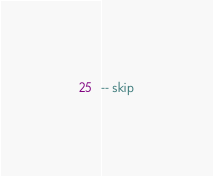<code> <loc_0><loc_0><loc_500><loc_500><_SQL_>-- skip
</code> 